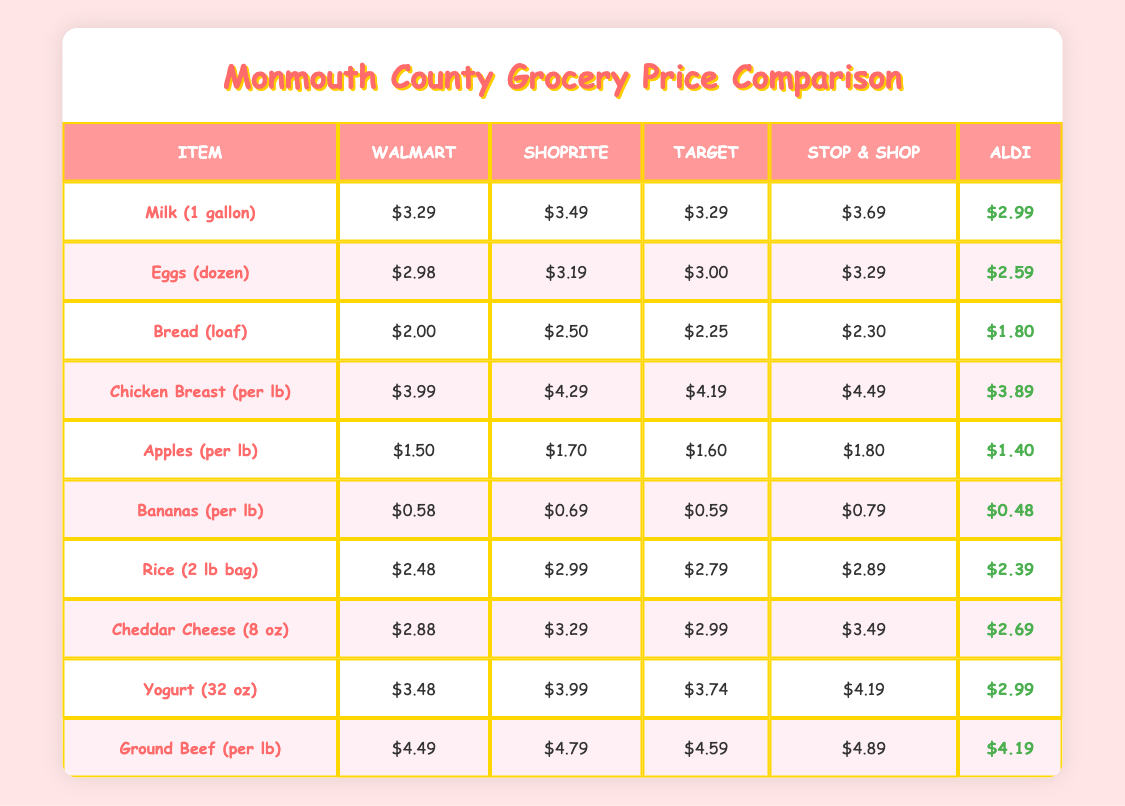What is the price of milk at Aldi? According to the table, Aldi sells milk for $2.99
Answer: $2.99 Which store has the best price for bananas? From the table, Aldi has the best price for bananas at $0.48, which is lower than the prices at Walmart, ShopRite, Target, and Stop & Shop
Answer: Aldi What is the total cost of buying a gallon of milk and a dozen eggs at Walmart? At Walmart, milk costs $3.29 and eggs cost $2.98. Adding these together gives $3.29 + $2.98 = $6.27
Answer: $6.27 Is the price of cheddar cheese higher at ShopRite than at Walmart? The table shows that cheddar cheese costs $3.29 at ShopRite and $2.88 at Walmart. Since $3.29 is greater than $2.88, this statement is true
Answer: Yes What is the average price of rice across all supermarkets? The prices of rice are: Walmart ($2.48), ShopRite ($2.99), Target ($2.79), Stop & Shop ($2.89), Aldi ($2.39). Adding them gives 2.48 + 2.99 + 2.79 + 2.89 + 2.39 = 13.54. Dividing by 5 (the number of stores) gives 13.54 / 5 = 2.708
Answer: $2.71 Which product is cheaper at Aldi compared to Walmart? From the table, we compare prices for all items. For example, bananas ($0.48 at Aldi vs. $0.58 at Walmart) and apples ($1.40 at Aldi vs. $1.50 at Walmart) are cheaper at Aldi
Answer: Bananas and apples Is the price of chicken breast the same at Target and Stop & Shop? From the prices listed, chicken breast costs $4.19 at Target and $4.49 at Stop & Shop. Since $4.19 is not equal to $4.49, they are not the same
Answer: No What is the price difference of a loaf of bread between Walmart and Aldi? Walmart sells bread for $2.00, while Aldi sells it for $1.80. The difference is calculated by $2.00 - $1.80 = $0.20
Answer: $0.20 What percentage of the total prices does ground beef represent if added to the total of all items in Walmart? First, we find the total price of all items at Walmart: $3.29 + $2.98 + $2.00 + $3.99 + $1.50 + $0.58 + $2.48 + $2.88 + $3.48 + $4.49 = $23.45. Ground beef costs $4.49. Now, dividing ground beef's price by the total gives $4.49 / $23.45 = 0.191, converting to percentage gives approximately 19.1%
Answer: 19.1% 